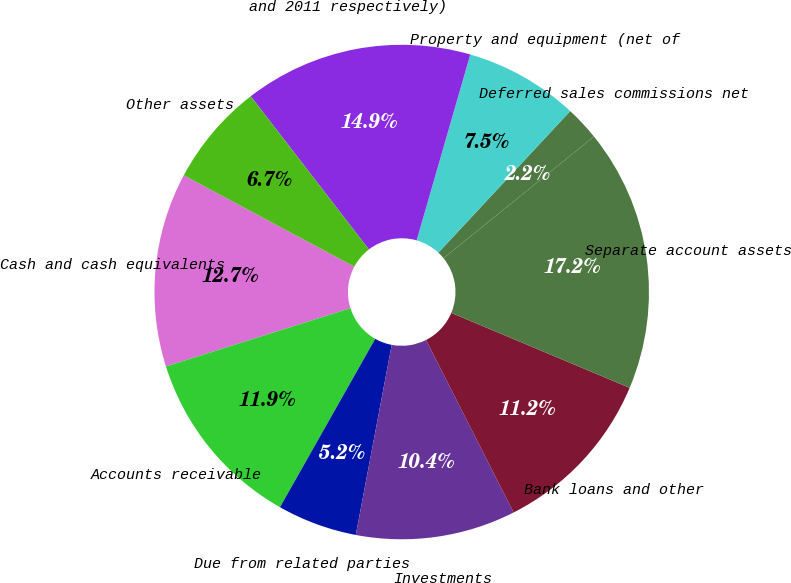Convert chart to OTSL. <chart><loc_0><loc_0><loc_500><loc_500><pie_chart><fcel>Cash and cash equivalents<fcel>Accounts receivable<fcel>Due from related parties<fcel>Investments<fcel>Bank loans and other<fcel>Separate account assets<fcel>Deferred sales commissions net<fcel>Property and equipment (net of<fcel>and 2011 respectively)<fcel>Other assets<nl><fcel>12.69%<fcel>11.94%<fcel>5.22%<fcel>10.45%<fcel>11.19%<fcel>17.16%<fcel>2.24%<fcel>7.46%<fcel>14.93%<fcel>6.72%<nl></chart> 